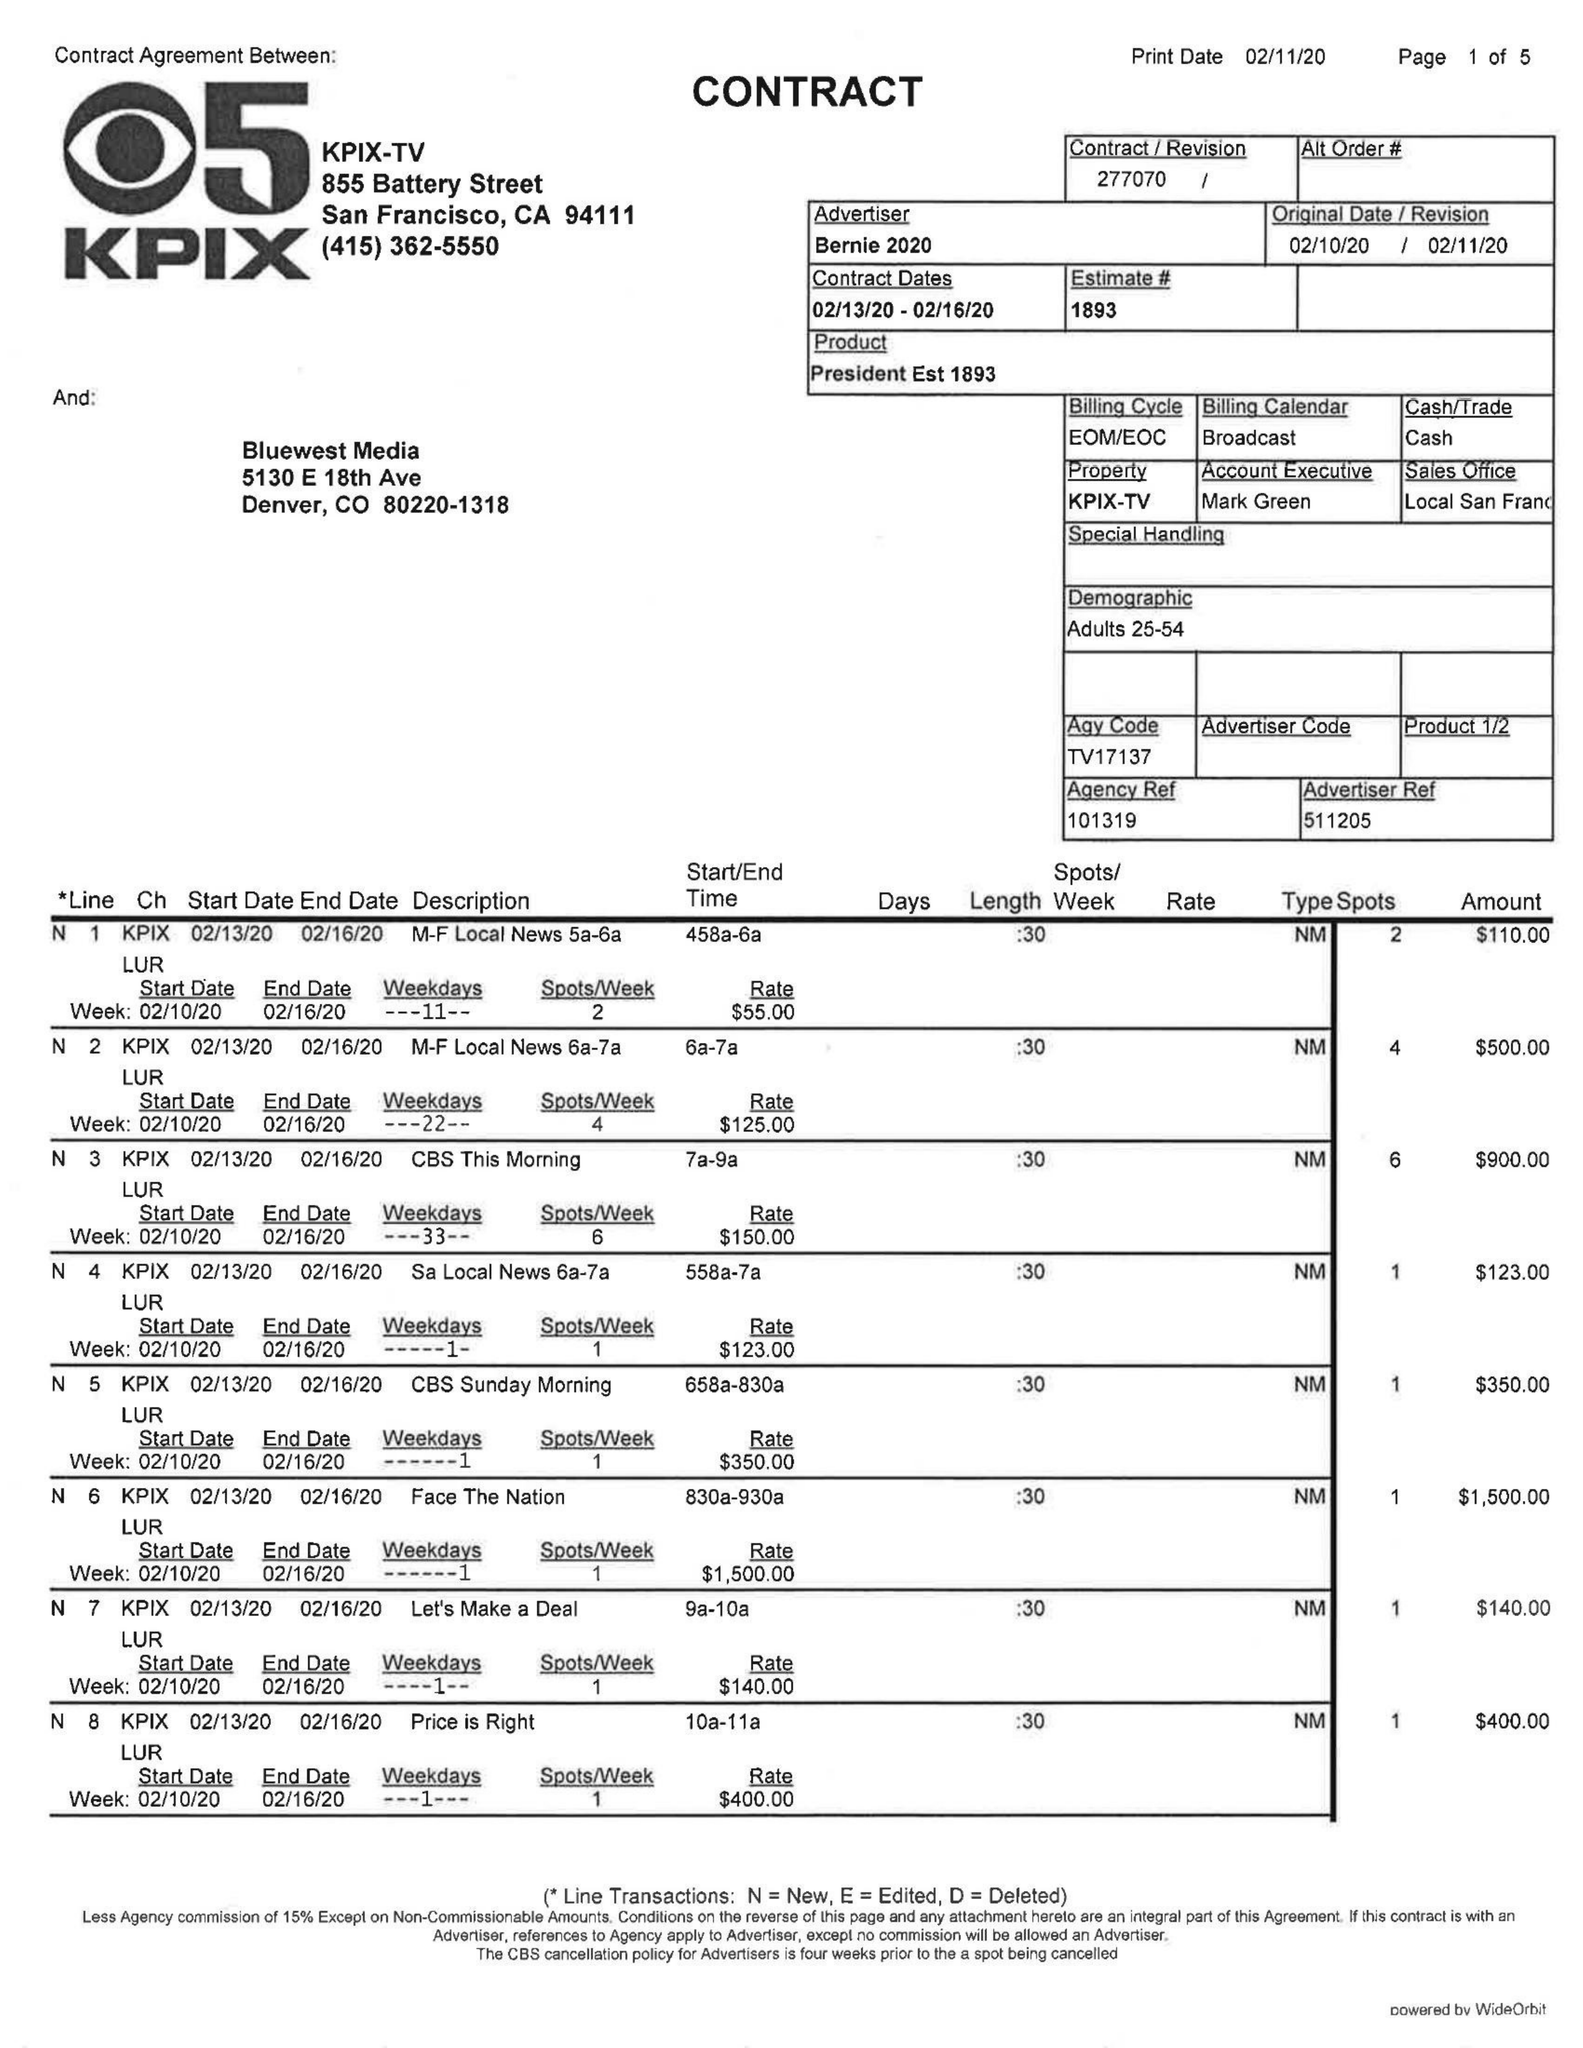What is the value for the flight_from?
Answer the question using a single word or phrase. 02/13/20 